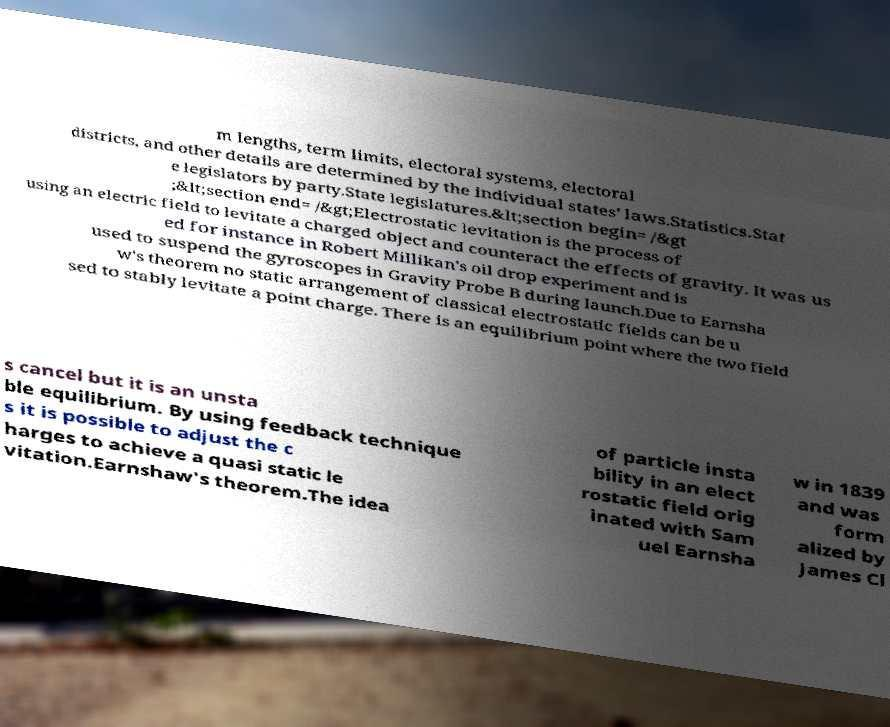Please read and relay the text visible in this image. What does it say? m lengths, term limits, electoral systems, electoral districts, and other details are determined by the individual states' laws.Statistics.Stat e legislators by party.State legislatures.&lt;section begin= /&gt ;&lt;section end= /&gt;Electrostatic levitation is the process of using an electric field to levitate a charged object and counteract the effects of gravity. It was us ed for instance in Robert Millikan's oil drop experiment and is used to suspend the gyroscopes in Gravity Probe B during launch.Due to Earnsha w's theorem no static arrangement of classical electrostatic fields can be u sed to stably levitate a point charge. There is an equilibrium point where the two field s cancel but it is an unsta ble equilibrium. By using feedback technique s it is possible to adjust the c harges to achieve a quasi static le vitation.Earnshaw's theorem.The idea of particle insta bility in an elect rostatic field orig inated with Sam uel Earnsha w in 1839 and was form alized by James Cl 